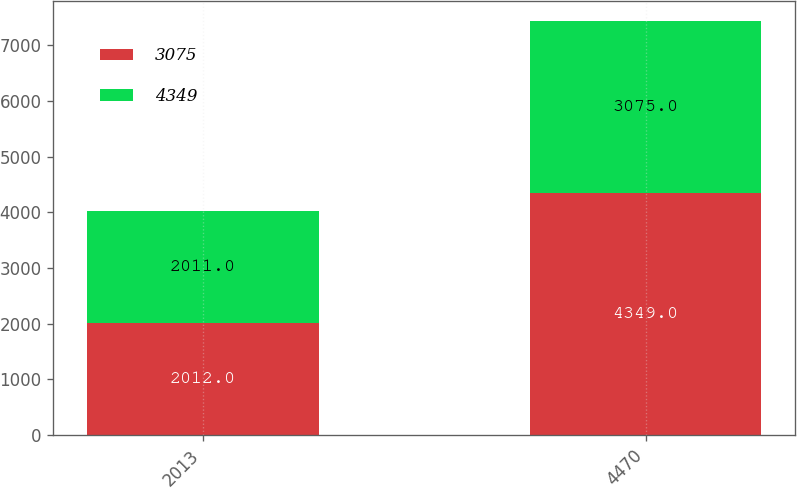Convert chart to OTSL. <chart><loc_0><loc_0><loc_500><loc_500><stacked_bar_chart><ecel><fcel>2013<fcel>4470<nl><fcel>3075<fcel>2012<fcel>4349<nl><fcel>4349<fcel>2011<fcel>3075<nl></chart> 